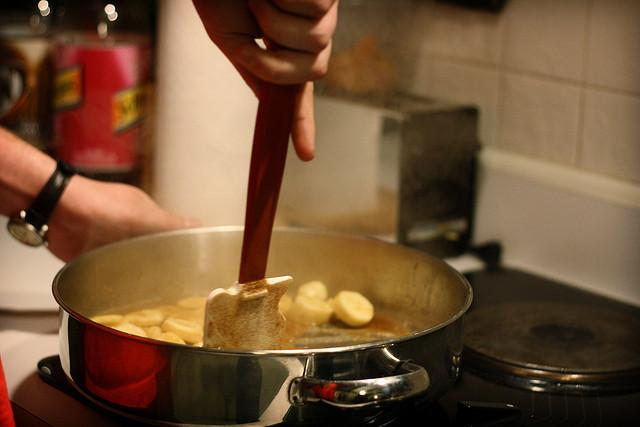What action is the person doing? Please explain your reasoning. stirring. They have a spatula in a pot. 